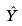Convert formula to latex. <formula><loc_0><loc_0><loc_500><loc_500>\hat { Y }</formula> 